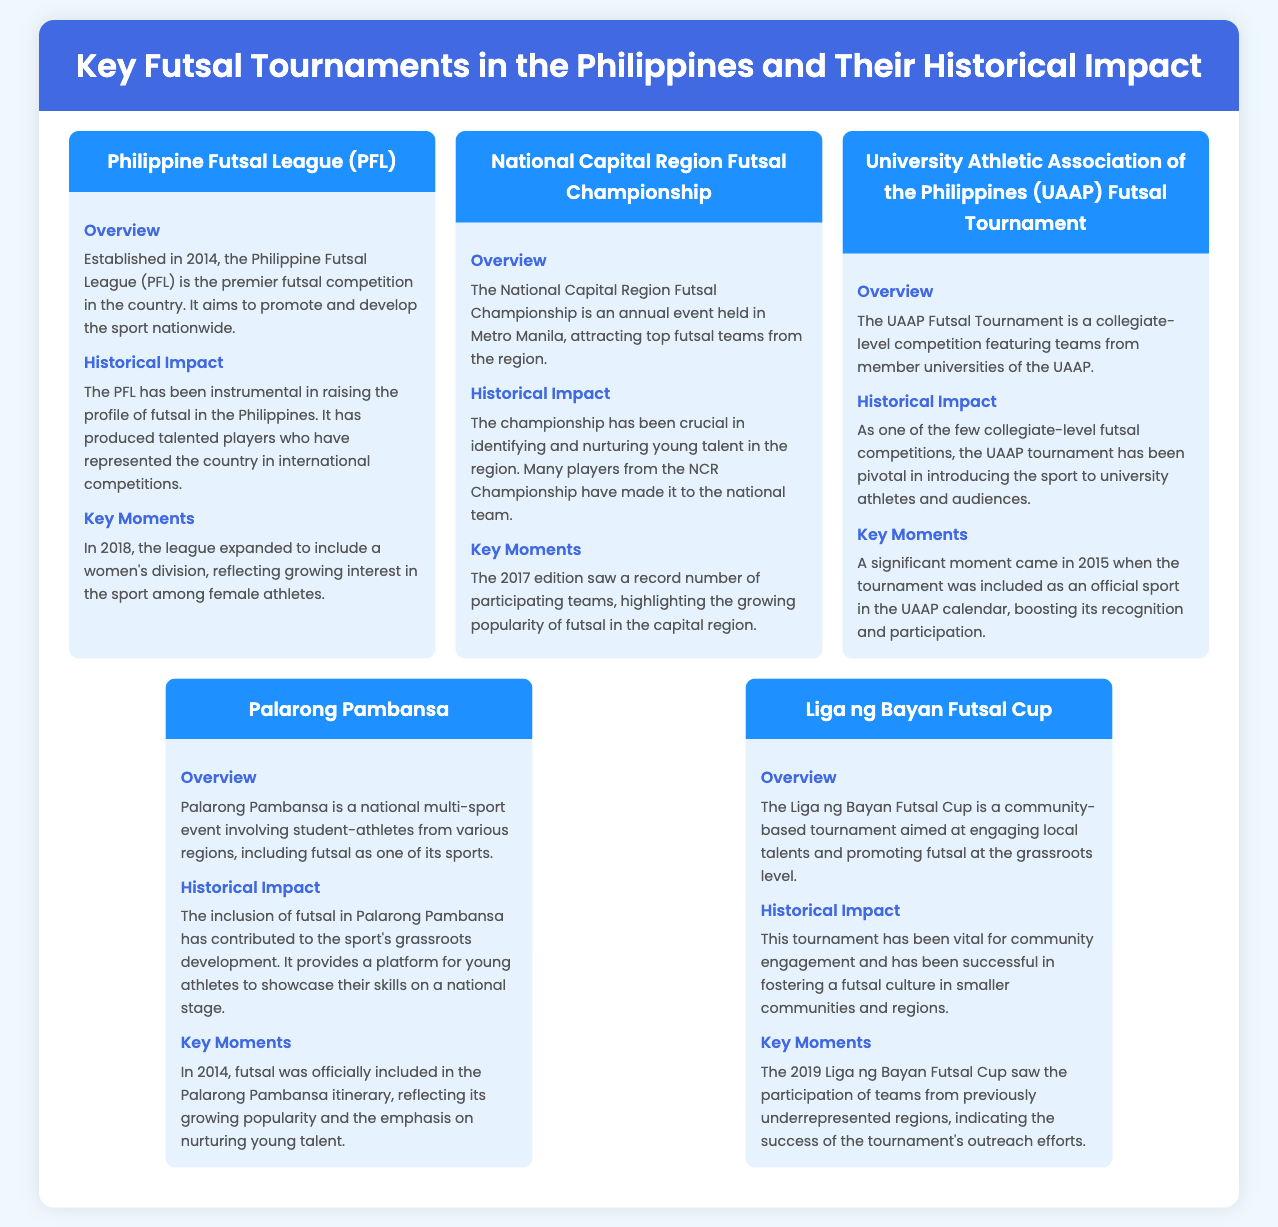What year was the Philippine Futsal League established? The document states that the Philippine Futsal League was established in 2014.
Answer: 2014 What is the purpose of the National Capital Region Futsal Championship? The document explains that the National Capital Region Futsal Championship aims to attract top futsal teams from the region.
Answer: Attract top futsal teams When was the UAAP Futsal Tournament included as an official sport? The document specifies that the significant moment for the UAAP Futsal Tournament was in 2015 when it became an official sport.
Answer: 2015 What impact has Palarong Pambansa had on futsal? According to the document, Palarong Pambansa has contributed to the grassroots development of futsal in the Philippines.
Answer: Grassroots development What is the significance of the Liga ng Bayan Futsal Cup? The document states that the Liga ng Bayan Futsal Cup is vital for community engagement and promoting futsal at the grassroots level.
Answer: Community engagement How many divisions did the Philippine Futsal League expand to include in 2018? The document indicates that the league expanded to include a women's division in 2018.
Answer: Women's division What was the notable achievement of the 2017 National Capital Region Futsal Championship? The document notes that the 2017 edition saw a record number of participating teams, underlining its popularity.
Answer: Record number of teams What year was futsal officially included in the Palarong Pambansa itinerary? According to the document, futsal was officially included in the Palarong Pambansa itinerary in 2014.
Answer: 2014 What region does the Liga ng Bayan Futsal Cup primarily focus on? The document explains that the Liga ng Bayan Futsal Cup is aimed at engaging local talents and promoting futsal at the grassroots level in smaller communities and regions.
Answer: Smaller communities and regions 